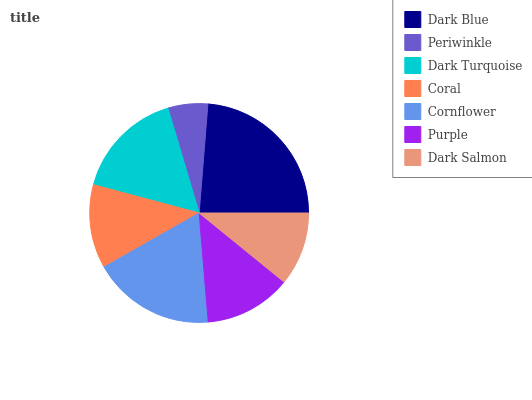Is Periwinkle the minimum?
Answer yes or no. Yes. Is Dark Blue the maximum?
Answer yes or no. Yes. Is Dark Turquoise the minimum?
Answer yes or no. No. Is Dark Turquoise the maximum?
Answer yes or no. No. Is Dark Turquoise greater than Periwinkle?
Answer yes or no. Yes. Is Periwinkle less than Dark Turquoise?
Answer yes or no. Yes. Is Periwinkle greater than Dark Turquoise?
Answer yes or no. No. Is Dark Turquoise less than Periwinkle?
Answer yes or no. No. Is Purple the high median?
Answer yes or no. Yes. Is Purple the low median?
Answer yes or no. Yes. Is Periwinkle the high median?
Answer yes or no. No. Is Coral the low median?
Answer yes or no. No. 